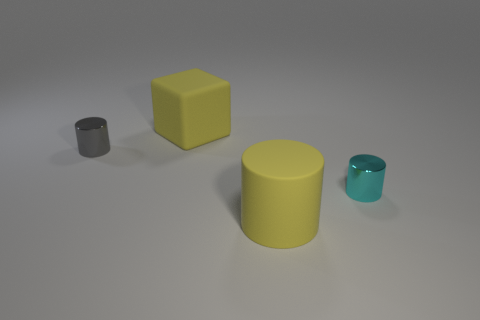Add 3 yellow blocks. How many objects exist? 7 Subtract all red cylinders. Subtract all blue cubes. How many cylinders are left? 3 Subtract all blocks. How many objects are left? 3 Subtract all large purple matte blocks. Subtract all large cylinders. How many objects are left? 3 Add 3 cyan things. How many cyan things are left? 4 Add 3 large cyan matte cylinders. How many large cyan matte cylinders exist? 3 Subtract 1 yellow blocks. How many objects are left? 3 